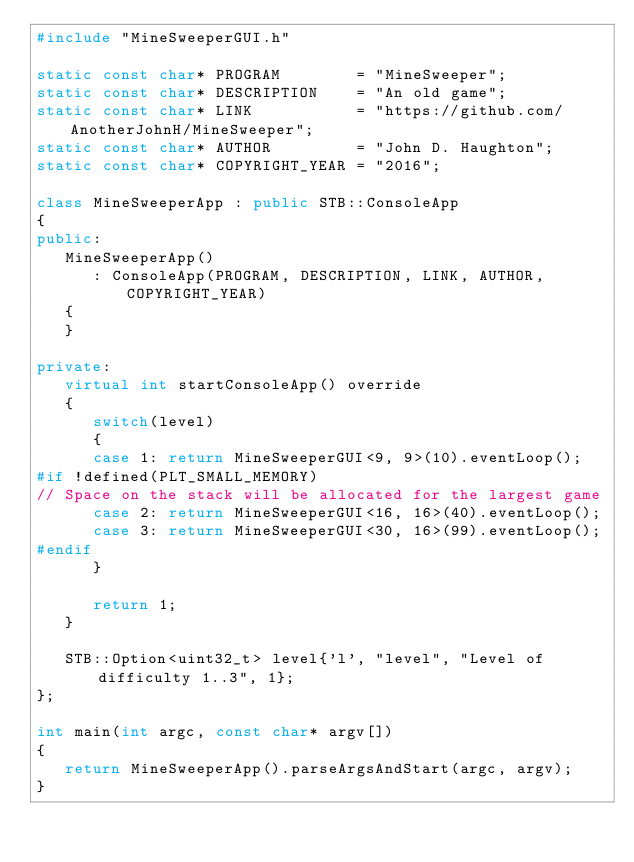Convert code to text. <code><loc_0><loc_0><loc_500><loc_500><_C++_>#include "MineSweeperGUI.h"

static const char* PROGRAM        = "MineSweeper";
static const char* DESCRIPTION    = "An old game";
static const char* LINK           = "https://github.com/AnotherJohnH/MineSweeper";
static const char* AUTHOR         = "John D. Haughton";
static const char* COPYRIGHT_YEAR = "2016";

class MineSweeperApp : public STB::ConsoleApp
{
public:
   MineSweeperApp()
      : ConsoleApp(PROGRAM, DESCRIPTION, LINK, AUTHOR, COPYRIGHT_YEAR)
   {
   }

private:
   virtual int startConsoleApp() override
   {
      switch(level)
      {
      case 1: return MineSweeperGUI<9, 9>(10).eventLoop();
#if !defined(PLT_SMALL_MEMORY)
// Space on the stack will be allocated for the largest game
      case 2: return MineSweeperGUI<16, 16>(40).eventLoop();
      case 3: return MineSweeperGUI<30, 16>(99).eventLoop();
#endif
      }

      return 1;
   }

   STB::Option<uint32_t> level{'l', "level", "Level of difficulty 1..3", 1};
};

int main(int argc, const char* argv[])
{
   return MineSweeperApp().parseArgsAndStart(argc, argv);
}
</code> 